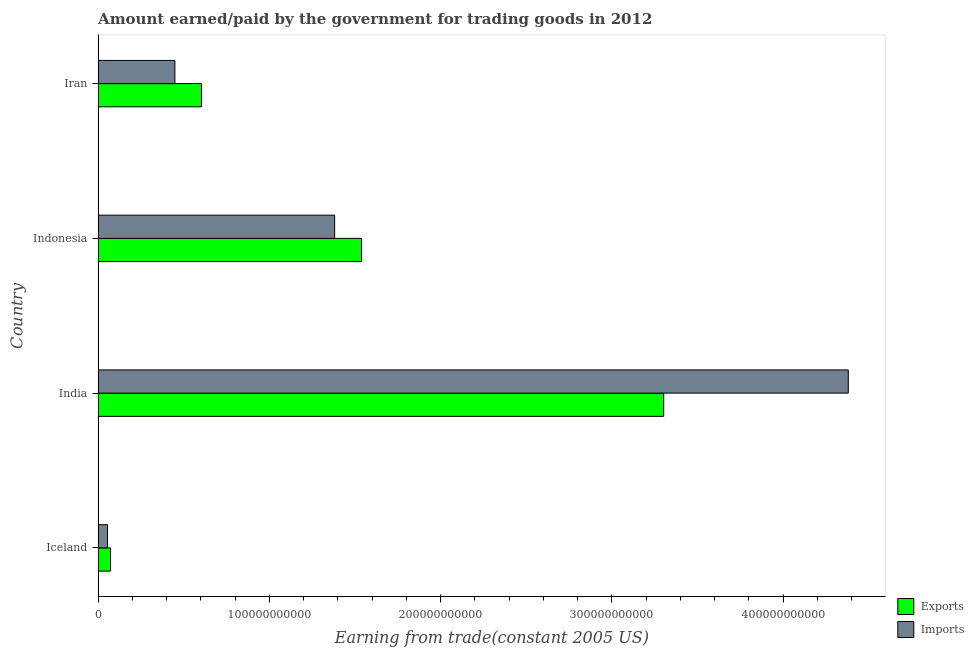How many different coloured bars are there?
Your response must be concise. 2. How many bars are there on the 2nd tick from the top?
Provide a succinct answer. 2. How many bars are there on the 3rd tick from the bottom?
Provide a short and direct response. 2. What is the label of the 3rd group of bars from the top?
Your answer should be compact. India. In how many cases, is the number of bars for a given country not equal to the number of legend labels?
Give a very brief answer. 0. What is the amount earned from exports in Iceland?
Your answer should be very brief. 7.27e+09. Across all countries, what is the maximum amount paid for imports?
Give a very brief answer. 4.38e+11. Across all countries, what is the minimum amount earned from exports?
Give a very brief answer. 7.27e+09. In which country was the amount earned from exports maximum?
Your answer should be compact. India. What is the total amount paid for imports in the graph?
Provide a short and direct response. 6.26e+11. What is the difference between the amount paid for imports in Indonesia and that in Iran?
Your answer should be very brief. 9.33e+1. What is the difference between the amount earned from exports in Iceland and the amount paid for imports in India?
Keep it short and to the point. -4.31e+11. What is the average amount paid for imports per country?
Provide a short and direct response. 1.57e+11. What is the difference between the amount paid for imports and amount earned from exports in India?
Keep it short and to the point. 1.08e+11. In how many countries, is the amount earned from exports greater than 60000000000 US$?
Provide a short and direct response. 3. What is the ratio of the amount paid for imports in Iceland to that in Indonesia?
Your answer should be very brief. 0.04. Is the difference between the amount paid for imports in Iceland and Indonesia greater than the difference between the amount earned from exports in Iceland and Indonesia?
Offer a terse response. Yes. What is the difference between the highest and the second highest amount paid for imports?
Your response must be concise. 3.00e+11. What is the difference between the highest and the lowest amount paid for imports?
Provide a short and direct response. 4.33e+11. In how many countries, is the amount paid for imports greater than the average amount paid for imports taken over all countries?
Your answer should be very brief. 1. What does the 1st bar from the top in Iceland represents?
Your answer should be very brief. Imports. What does the 2nd bar from the bottom in Iran represents?
Give a very brief answer. Imports. How many bars are there?
Provide a succinct answer. 8. How many countries are there in the graph?
Offer a very short reply. 4. What is the difference between two consecutive major ticks on the X-axis?
Provide a succinct answer. 1.00e+11. Does the graph contain any zero values?
Offer a terse response. No. How are the legend labels stacked?
Your response must be concise. Vertical. What is the title of the graph?
Keep it short and to the point. Amount earned/paid by the government for trading goods in 2012. What is the label or title of the X-axis?
Keep it short and to the point. Earning from trade(constant 2005 US). What is the label or title of the Y-axis?
Offer a terse response. Country. What is the Earning from trade(constant 2005 US) of Exports in Iceland?
Make the answer very short. 7.27e+09. What is the Earning from trade(constant 2005 US) in Imports in Iceland?
Ensure brevity in your answer.  5.49e+09. What is the Earning from trade(constant 2005 US) in Exports in India?
Give a very brief answer. 3.30e+11. What is the Earning from trade(constant 2005 US) of Imports in India?
Provide a succinct answer. 4.38e+11. What is the Earning from trade(constant 2005 US) of Exports in Indonesia?
Provide a short and direct response. 1.54e+11. What is the Earning from trade(constant 2005 US) in Imports in Indonesia?
Provide a succinct answer. 1.38e+11. What is the Earning from trade(constant 2005 US) of Exports in Iran?
Your answer should be very brief. 6.03e+1. What is the Earning from trade(constant 2005 US) in Imports in Iran?
Ensure brevity in your answer.  4.48e+1. Across all countries, what is the maximum Earning from trade(constant 2005 US) of Exports?
Provide a short and direct response. 3.30e+11. Across all countries, what is the maximum Earning from trade(constant 2005 US) of Imports?
Your answer should be compact. 4.38e+11. Across all countries, what is the minimum Earning from trade(constant 2005 US) in Exports?
Your answer should be very brief. 7.27e+09. Across all countries, what is the minimum Earning from trade(constant 2005 US) of Imports?
Your response must be concise. 5.49e+09. What is the total Earning from trade(constant 2005 US) in Exports in the graph?
Give a very brief answer. 5.52e+11. What is the total Earning from trade(constant 2005 US) of Imports in the graph?
Give a very brief answer. 6.26e+11. What is the difference between the Earning from trade(constant 2005 US) of Exports in Iceland and that in India?
Your response must be concise. -3.23e+11. What is the difference between the Earning from trade(constant 2005 US) of Imports in Iceland and that in India?
Provide a short and direct response. -4.33e+11. What is the difference between the Earning from trade(constant 2005 US) in Exports in Iceland and that in Indonesia?
Give a very brief answer. -1.47e+11. What is the difference between the Earning from trade(constant 2005 US) of Imports in Iceland and that in Indonesia?
Provide a short and direct response. -1.33e+11. What is the difference between the Earning from trade(constant 2005 US) in Exports in Iceland and that in Iran?
Provide a short and direct response. -5.31e+1. What is the difference between the Earning from trade(constant 2005 US) in Imports in Iceland and that in Iran?
Offer a very short reply. -3.93e+1. What is the difference between the Earning from trade(constant 2005 US) of Exports in India and that in Indonesia?
Ensure brevity in your answer.  1.76e+11. What is the difference between the Earning from trade(constant 2005 US) of Imports in India and that in Indonesia?
Keep it short and to the point. 3.00e+11. What is the difference between the Earning from trade(constant 2005 US) of Exports in India and that in Iran?
Make the answer very short. 2.70e+11. What is the difference between the Earning from trade(constant 2005 US) in Imports in India and that in Iran?
Keep it short and to the point. 3.93e+11. What is the difference between the Earning from trade(constant 2005 US) of Exports in Indonesia and that in Iran?
Keep it short and to the point. 9.34e+1. What is the difference between the Earning from trade(constant 2005 US) in Imports in Indonesia and that in Iran?
Keep it short and to the point. 9.33e+1. What is the difference between the Earning from trade(constant 2005 US) in Exports in Iceland and the Earning from trade(constant 2005 US) in Imports in India?
Make the answer very short. -4.31e+11. What is the difference between the Earning from trade(constant 2005 US) in Exports in Iceland and the Earning from trade(constant 2005 US) in Imports in Indonesia?
Keep it short and to the point. -1.31e+11. What is the difference between the Earning from trade(constant 2005 US) of Exports in Iceland and the Earning from trade(constant 2005 US) of Imports in Iran?
Keep it short and to the point. -3.76e+1. What is the difference between the Earning from trade(constant 2005 US) of Exports in India and the Earning from trade(constant 2005 US) of Imports in Indonesia?
Ensure brevity in your answer.  1.92e+11. What is the difference between the Earning from trade(constant 2005 US) of Exports in India and the Earning from trade(constant 2005 US) of Imports in Iran?
Provide a succinct answer. 2.85e+11. What is the difference between the Earning from trade(constant 2005 US) of Exports in Indonesia and the Earning from trade(constant 2005 US) of Imports in Iran?
Your answer should be compact. 1.09e+11. What is the average Earning from trade(constant 2005 US) of Exports per country?
Ensure brevity in your answer.  1.38e+11. What is the average Earning from trade(constant 2005 US) of Imports per country?
Keep it short and to the point. 1.57e+11. What is the difference between the Earning from trade(constant 2005 US) in Exports and Earning from trade(constant 2005 US) in Imports in Iceland?
Offer a very short reply. 1.78e+09. What is the difference between the Earning from trade(constant 2005 US) of Exports and Earning from trade(constant 2005 US) of Imports in India?
Make the answer very short. -1.08e+11. What is the difference between the Earning from trade(constant 2005 US) in Exports and Earning from trade(constant 2005 US) in Imports in Indonesia?
Make the answer very short. 1.57e+1. What is the difference between the Earning from trade(constant 2005 US) in Exports and Earning from trade(constant 2005 US) in Imports in Iran?
Your answer should be very brief. 1.55e+1. What is the ratio of the Earning from trade(constant 2005 US) in Exports in Iceland to that in India?
Ensure brevity in your answer.  0.02. What is the ratio of the Earning from trade(constant 2005 US) in Imports in Iceland to that in India?
Provide a short and direct response. 0.01. What is the ratio of the Earning from trade(constant 2005 US) in Exports in Iceland to that in Indonesia?
Offer a terse response. 0.05. What is the ratio of the Earning from trade(constant 2005 US) of Imports in Iceland to that in Indonesia?
Offer a very short reply. 0.04. What is the ratio of the Earning from trade(constant 2005 US) in Exports in Iceland to that in Iran?
Give a very brief answer. 0.12. What is the ratio of the Earning from trade(constant 2005 US) of Imports in Iceland to that in Iran?
Offer a very short reply. 0.12. What is the ratio of the Earning from trade(constant 2005 US) of Exports in India to that in Indonesia?
Your response must be concise. 2.15. What is the ratio of the Earning from trade(constant 2005 US) in Imports in India to that in Indonesia?
Provide a succinct answer. 3.17. What is the ratio of the Earning from trade(constant 2005 US) in Exports in India to that in Iran?
Provide a succinct answer. 5.47. What is the ratio of the Earning from trade(constant 2005 US) in Imports in India to that in Iran?
Offer a very short reply. 9.77. What is the ratio of the Earning from trade(constant 2005 US) in Exports in Indonesia to that in Iran?
Keep it short and to the point. 2.55. What is the ratio of the Earning from trade(constant 2005 US) of Imports in Indonesia to that in Iran?
Your answer should be compact. 3.08. What is the difference between the highest and the second highest Earning from trade(constant 2005 US) of Exports?
Provide a short and direct response. 1.76e+11. What is the difference between the highest and the second highest Earning from trade(constant 2005 US) in Imports?
Provide a succinct answer. 3.00e+11. What is the difference between the highest and the lowest Earning from trade(constant 2005 US) in Exports?
Offer a terse response. 3.23e+11. What is the difference between the highest and the lowest Earning from trade(constant 2005 US) in Imports?
Your answer should be compact. 4.33e+11. 